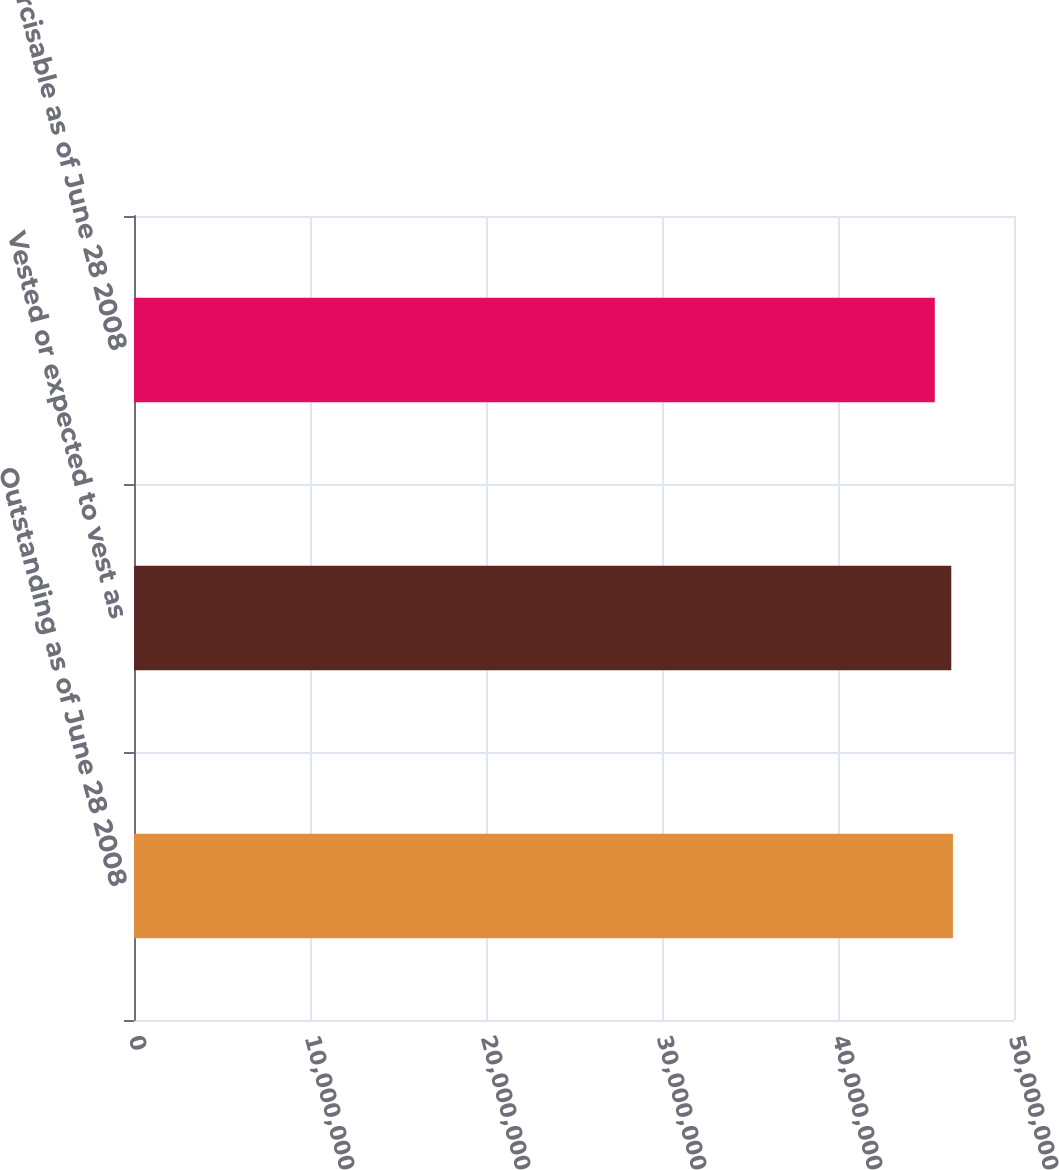Convert chart to OTSL. <chart><loc_0><loc_0><loc_500><loc_500><bar_chart><fcel>Outstanding as of June 28 2008<fcel>Vested or expected to vest as<fcel>Exercisable as of June 28 2008<nl><fcel>4.653e+07<fcel>4.6436e+07<fcel>4.5499e+07<nl></chart> 